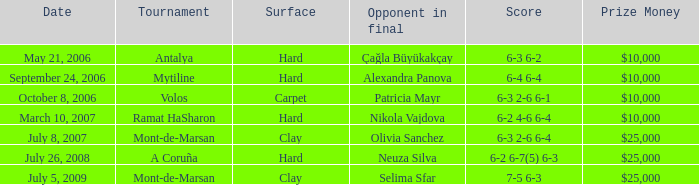What was the match's score on september 24, 2006? 6-4 6-4. 